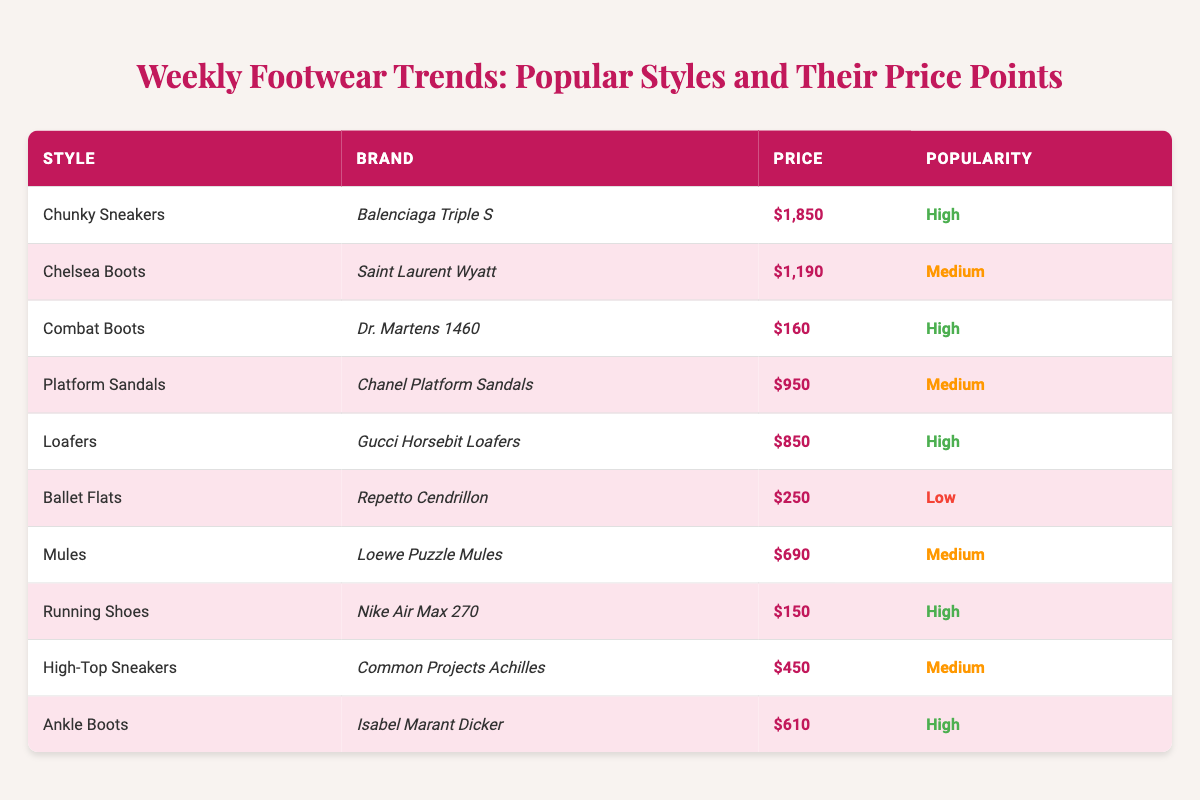What is the price of the Balenciaga Triple S shoes? The table lists the brand with the corresponding price. The Balenciaga Triple S is priced at $1,850.
Answer: $1,850 Which footwear style has the highest price? To determine the highest price, compare all prices listed in the table. The Chunky Sneakers by Balenciaga Triple S are the most expensive at $1,850.
Answer: Chunky Sneakers How many styles are categorized as 'High' in popularity? The table contains a popularity column. Counting the entries marked as 'High', there are 5 styles with high popularity.
Answer: 5 What is the price difference between the cheapest and the most expensive footwear? The cheapest is the Nike Air Max 270 at $150, and the most expensive is the Balenciaga Triple S at $1,850. The difference is calculated as $1,850 - $150 = $1,700.
Answer: $1,700 Are there any styles priced under $300? Checking the price column, the Ballet Flats at $250 and Running Shoes at $150 are below $300.
Answer: Yes Which style has the lowest popularity index? The popularity rankings are displayed in the table; Ballet Flats hold the lowest rank with 'Low'.
Answer: Ballet Flats What is the average price of the styles listed in the 'Medium' popularity category? The prices for medium popularity are $1,190 (Chelsea Boots), $950 (Platform Sandals), $690 (Mules), and $450 (High-Top Sneakers). Summing these gives $1,190 + $950 + $690 + $450 = $3,280. Dividing by the count of 4 styles yields an average of $3,280 / 4 = $820.
Answer: $820 Is there a style from Gucci in the table? Reviewing the brand column, the Gucci Horsebit Loafers are indeed listed.
Answer: Yes What is the combined price of all footwear styles with a 'High' popularity index? The high popularity styles and their prices are: Chunky Sneakers ($1,850), Combat Boots ($160), Loafers ($850), Running Shoes ($150), and Ankle Boots ($610). Adding these gives $1,850 + $160 + $850 + $150 + $610 = $2,820.
Answer: $2,820 Which footwear style is associated with Chanel? The table specifies that the Chanel brand is linked to the Platform Sandals.
Answer: Platform Sandals 